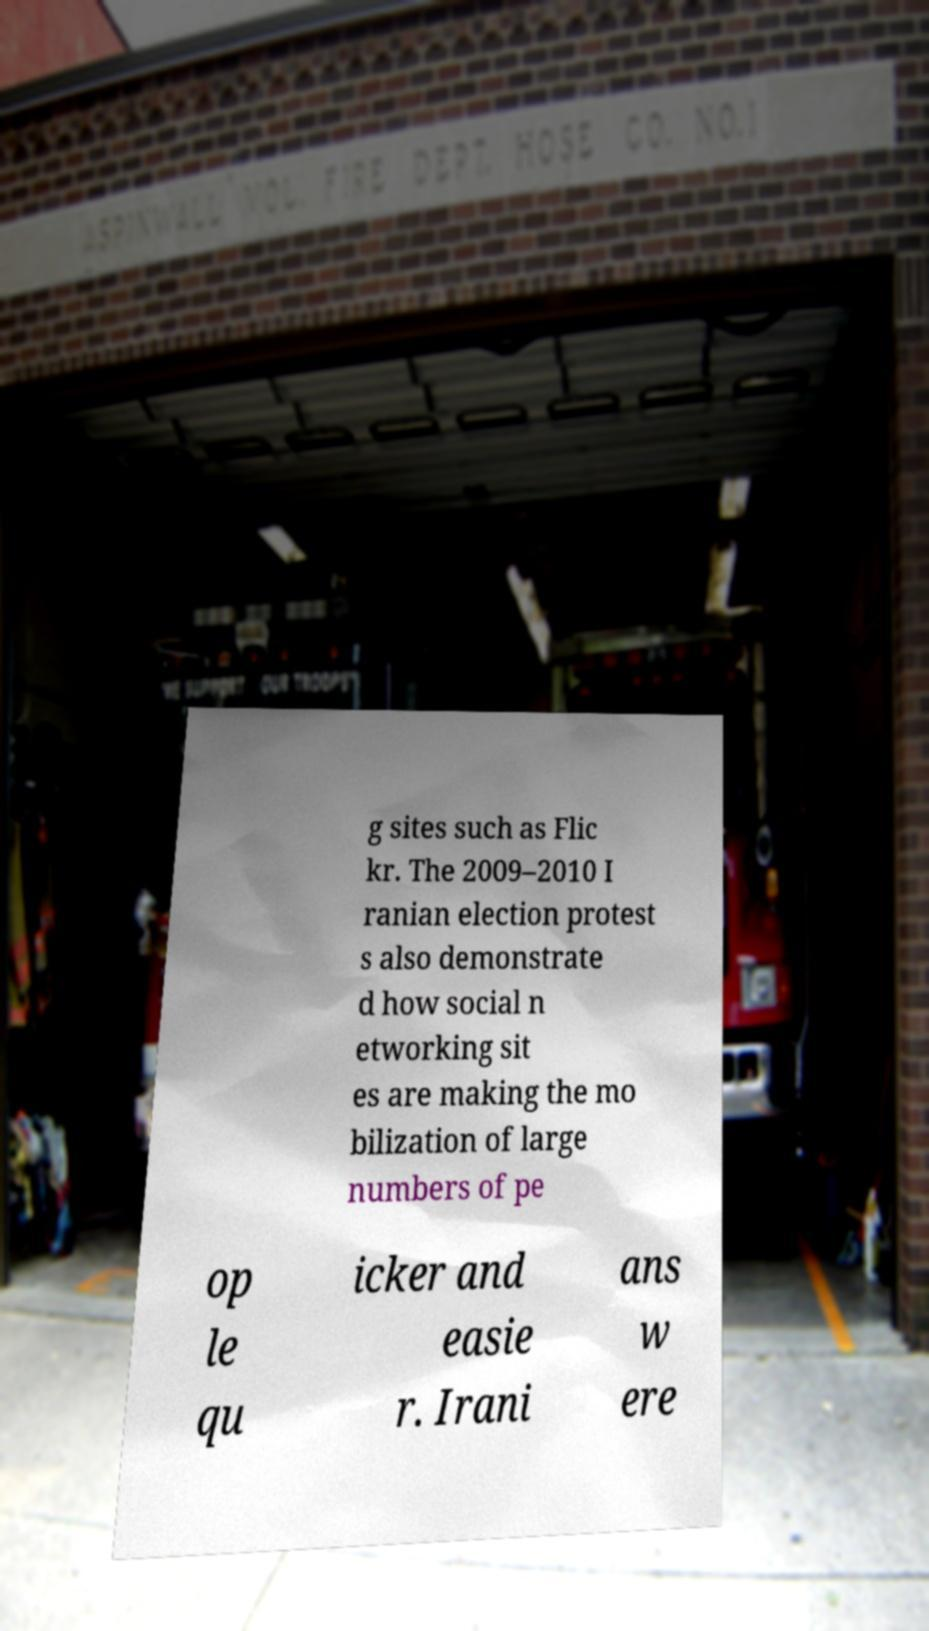Please read and relay the text visible in this image. What does it say? g sites such as Flic kr. The 2009–2010 I ranian election protest s also demonstrate d how social n etworking sit es are making the mo bilization of large numbers of pe op le qu icker and easie r. Irani ans w ere 